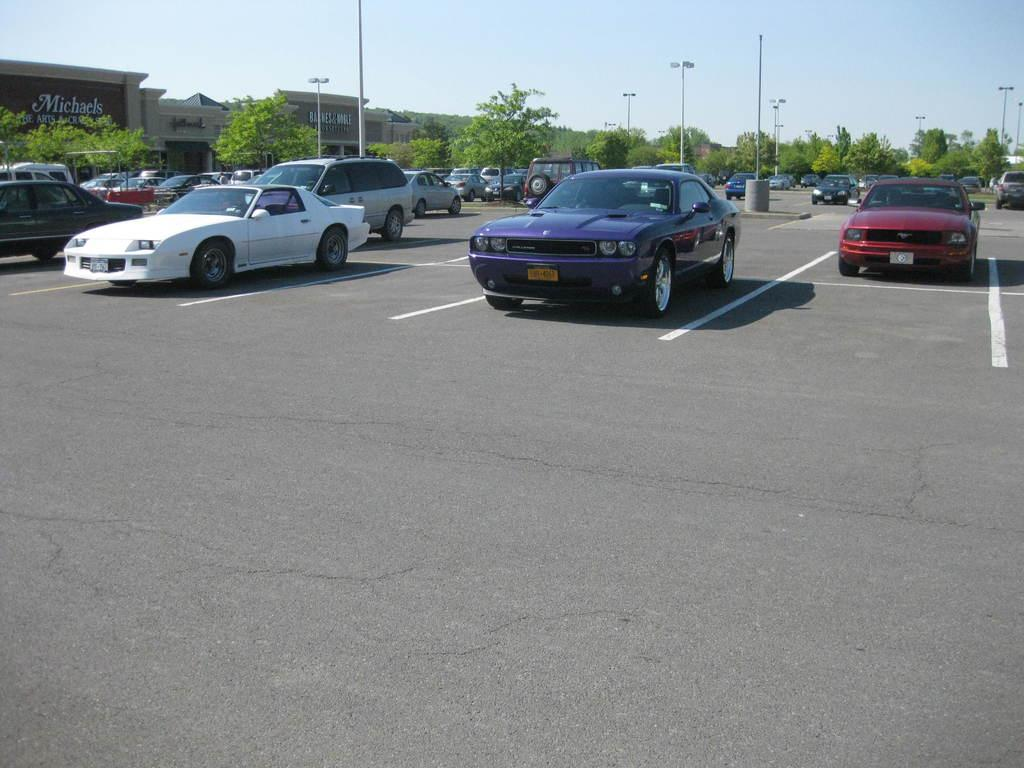What is the main subject of the image? The main subject of the image is many cars. Where are the cars located in the image? The cars are parked in a parking area. What can be seen in the background of the image? In the background of the image, there are street lights, poles, buildings, and the sky. What is the rate of paste production in the image? There is no mention of paste production or any industry in the image; it primarily features parked cars and background elements. 